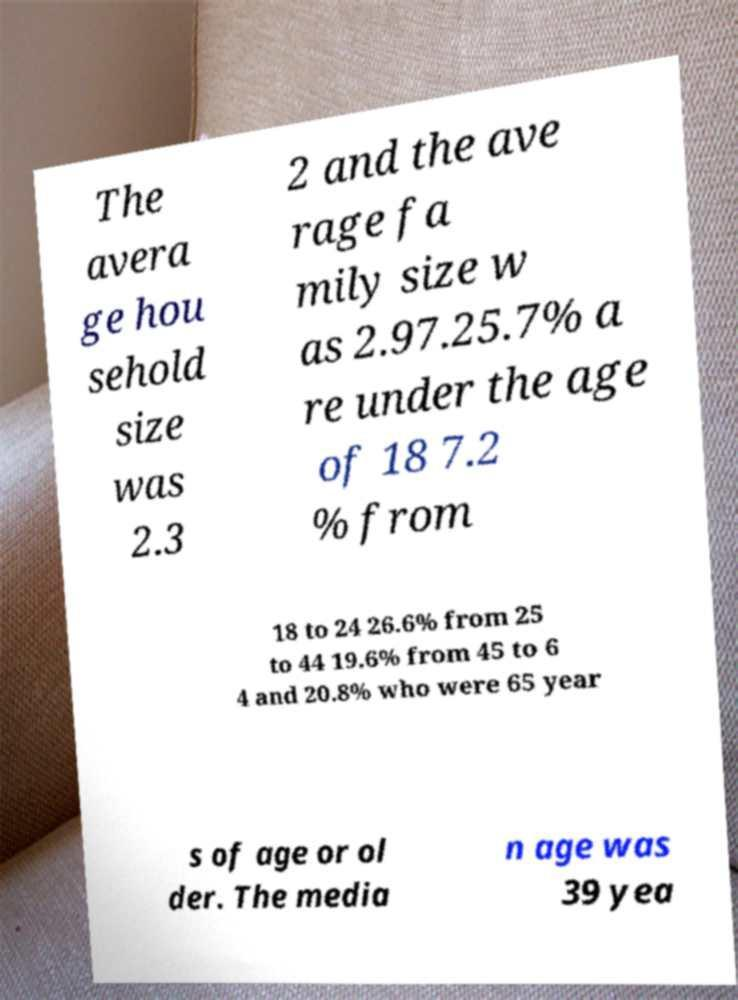Can you accurately transcribe the text from the provided image for me? The avera ge hou sehold size was 2.3 2 and the ave rage fa mily size w as 2.97.25.7% a re under the age of 18 7.2 % from 18 to 24 26.6% from 25 to 44 19.6% from 45 to 6 4 and 20.8% who were 65 year s of age or ol der. The media n age was 39 yea 